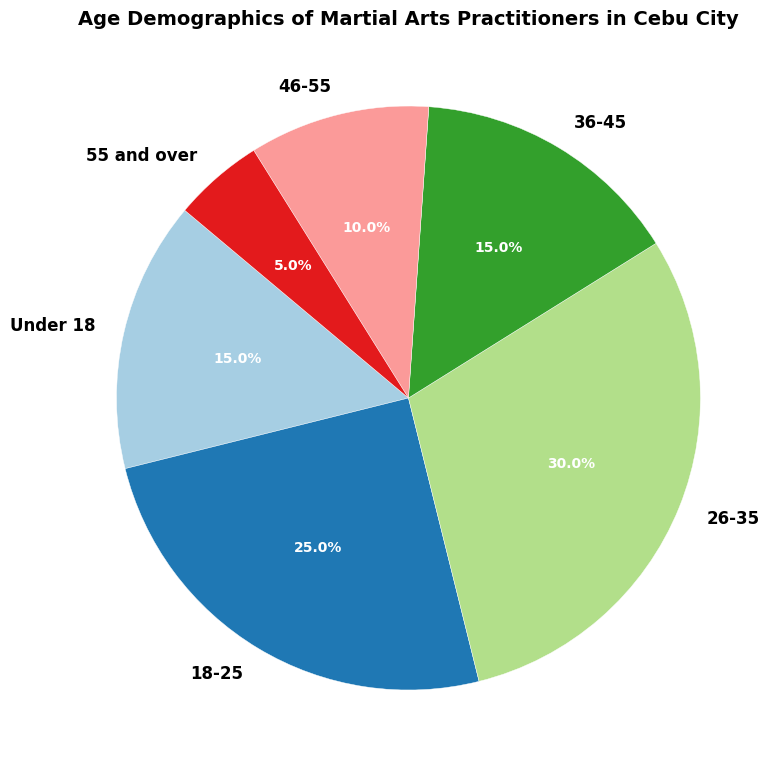What is the most represented age group among martial arts practitioners in Cebu City? The pie chart shows that the '26-35' age group has the highest percentage at 30%, making it the most represented group.
Answer: 26-35 Which two age groups have the same percentage of practitioners? The pie chart shows that both 'Under 18' and '36-45' age groups have a percentage of 15%.
Answer: Under 18 and 36-45 What percentage of practitioners are aged 46 and over? Sum the percentages of the '46-55' and '55 and over' age groups: 10% + 5% = 15%.
Answer: 15% Which age group has the smallest representation in the figure? The pie chart shows that the '55 and over' age group has the smallest percentage at 5%.
Answer: 55 and over How much larger is the percentage of the '18-25' age group compared to the '46-55' age group? Subtract the percentage of the '46-55' age group (10%) from the '18-25' age group (25%): 25% - 10% = 15%.
Answer: 15% If you combine the 'Under 18' and '18-25' age groups, what percentage of total practitioners do they represent? Add the percentages of the 'Under 18' and '18-25' age groups: 15% + 25% = 40%.
Answer: 40% What is the visual color used to represent the '36-45' age group? The color representing the '36-45' age group in the pie chart appears to be a shade of blue.
Answer: Blue Compare the representation of the '26-35' and '18-25' age groups. Which one is higher and by how much? The '26-35' age group has a percentage of 30%, while the '18-25' age group has a percentage of 25%. The '26-35' age group is higher by 5%.
Answer: 26-35 by 5% What's the total percentage of practitioners that are aged 35 and below? Sum the percentages of the 'Under 18', '18-25', and '26-35' age groups: 15% + 25% + 30% = 70%.
Answer: 70% 